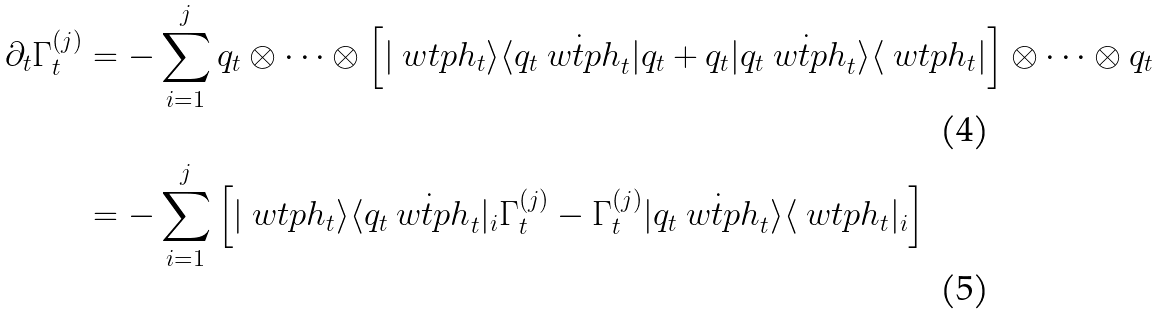Convert formula to latex. <formula><loc_0><loc_0><loc_500><loc_500>\partial _ { t } \Gamma _ { t } ^ { ( j ) } & = - \sum _ { i = 1 } ^ { j } q _ { t } \otimes \dots \otimes \left [ | \ w t p h _ { t } \rangle \langle q _ { t } \dot { \ w t p h } _ { t } | q _ { t } + q _ { t } | q _ { t } \dot { \ w t p h } _ { t } \rangle \langle \ w t p h _ { t } | \right ] \otimes \dots \otimes q _ { t } \\ & = - \sum _ { i = 1 } ^ { j } \left [ | \ w t p h _ { t } \rangle \langle q _ { t } \dot { \ w t p h } _ { t } | _ { i } \Gamma _ { t } ^ { ( j ) } - \Gamma _ { t } ^ { ( j ) } | q _ { t } \dot { \ w t p h } _ { t } \rangle \langle \ w t p h _ { t } | _ { i } \right ]</formula> 